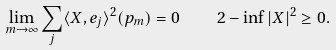Convert formula to latex. <formula><loc_0><loc_0><loc_500><loc_500>\lim _ { m \to \infty } \sum _ { j } \langle X , e _ { j } \rangle ^ { 2 } ( p _ { m } ) = 0 \quad 2 - \inf | X | ^ { 2 } \geq 0 .</formula> 